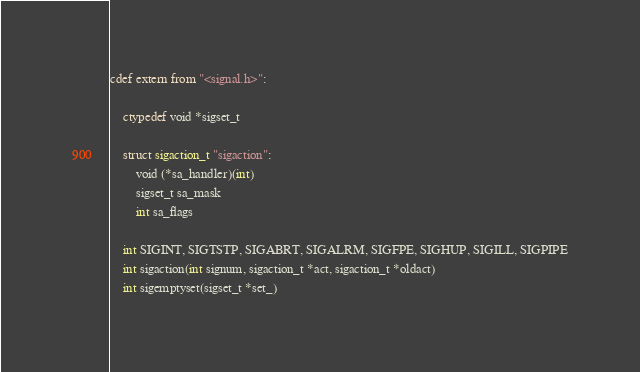<code> <loc_0><loc_0><loc_500><loc_500><_Cython_>
cdef extern from "<signal.h>":

    ctypedef void *sigset_t

    struct sigaction_t "sigaction":
        void (*sa_handler)(int)
        sigset_t sa_mask
        int sa_flags

    int SIGINT, SIGTSTP, SIGABRT, SIGALRM, SIGFPE, SIGHUP, SIGILL, SIGPIPE
    int sigaction(int signum, sigaction_t *act, sigaction_t *oldact)
    int sigemptyset(sigset_t *set_)</code> 